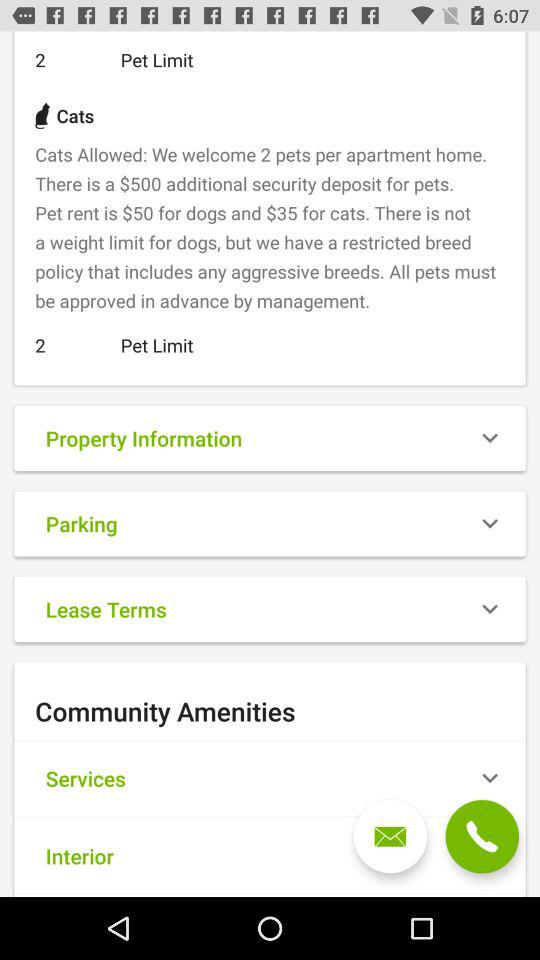What's the rent for dogs? The rent for dogs is $50. 